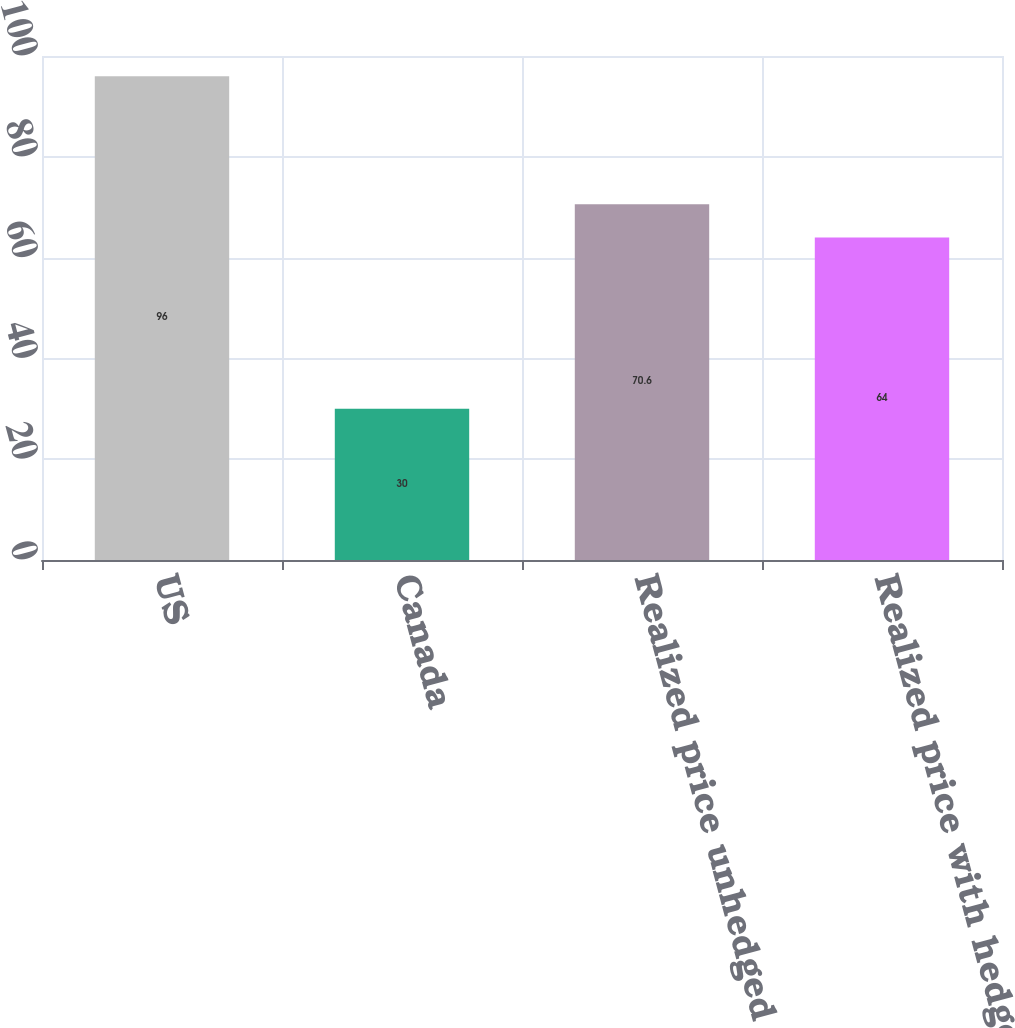<chart> <loc_0><loc_0><loc_500><loc_500><bar_chart><fcel>US<fcel>Canada<fcel>Realized price unhedged<fcel>Realized price with hedges<nl><fcel>96<fcel>30<fcel>70.6<fcel>64<nl></chart> 